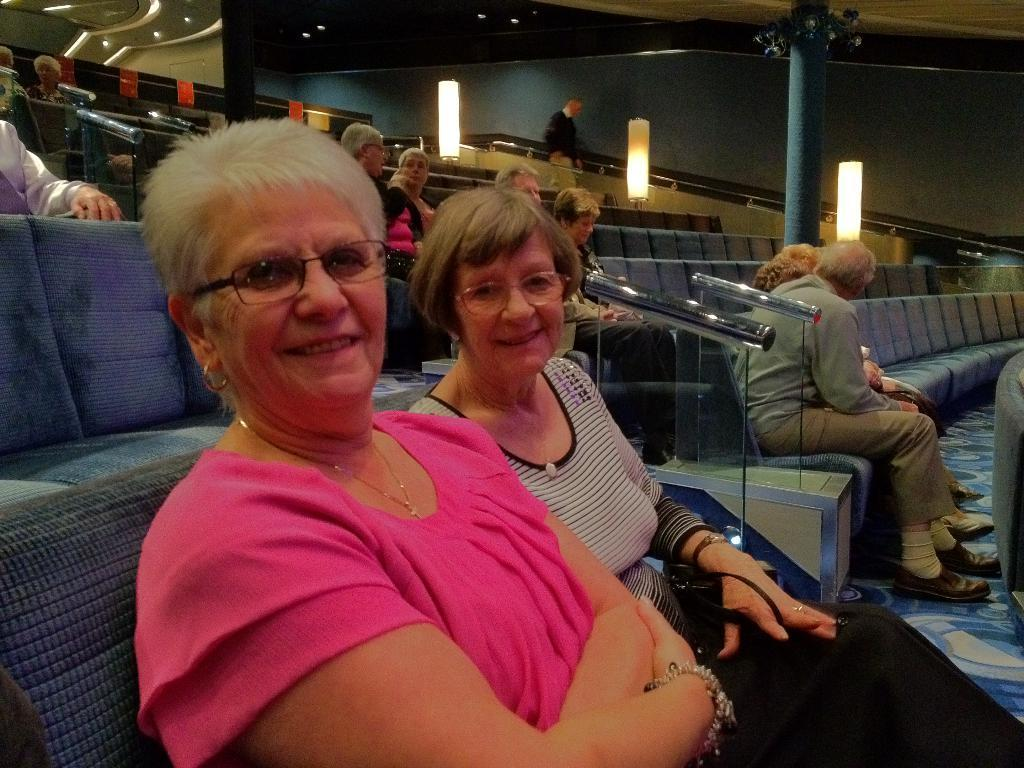What are the people in the image doing? The people in the image are sitting on chairs. What type of objects can be seen in the image? There are glass objects and many lamps in the image. What kind of space is depicted in the image? There is an auditorium in the image. What type of land can be seen in the image? There is no land visible in the image, as it is set in an auditorium. How many copies of the same glass object are present in the image? The image does not show multiple copies of the same glass object; it only shows one glass object. 